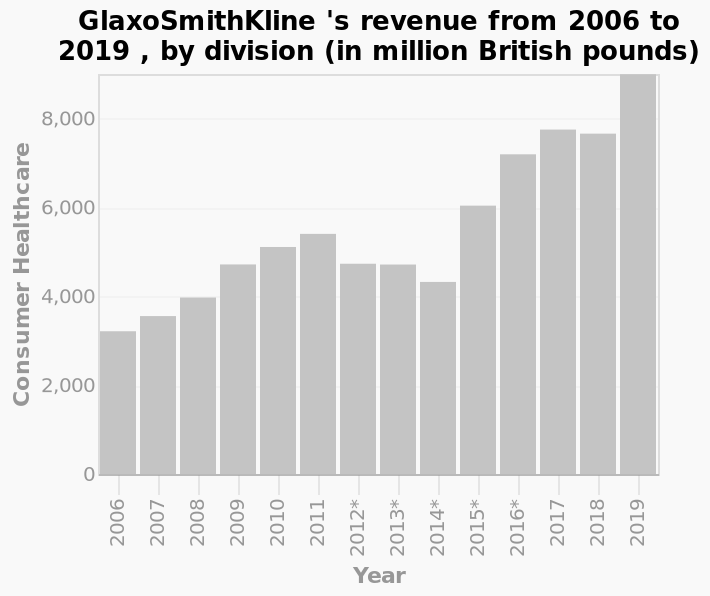<image>
please summary the statistics and relations of the chart Other than 2012-2014 GlaxoSmithKline’s profits have up each year. The profits in 2019 are considerably higher than in 2006. 